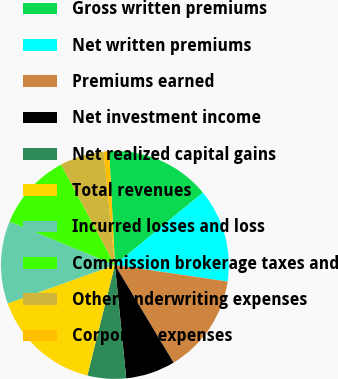<chart> <loc_0><loc_0><loc_500><loc_500><pie_chart><fcel>Gross written premiums<fcel>Net written premiums<fcel>Premiums earned<fcel>Net investment income<fcel>Net realized capital gains<fcel>Total revenues<fcel>Incurred losses and loss<fcel>Commission brokerage taxes and<fcel>Other underwriting expenses<fcel>Corporate expenses<nl><fcel>14.84%<fcel>13.28%<fcel>14.06%<fcel>7.03%<fcel>5.47%<fcel>15.62%<fcel>11.72%<fcel>10.94%<fcel>6.25%<fcel>0.79%<nl></chart> 